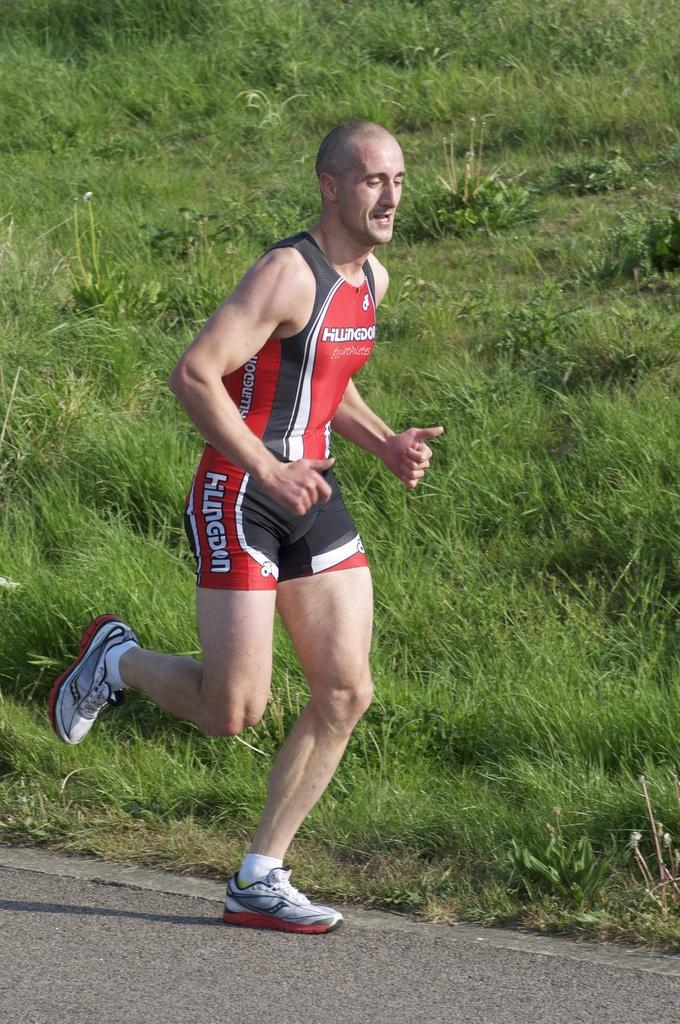Provide a one-sentence caption for the provided image. A runner has the word triathletes on the chest of his shirt. 